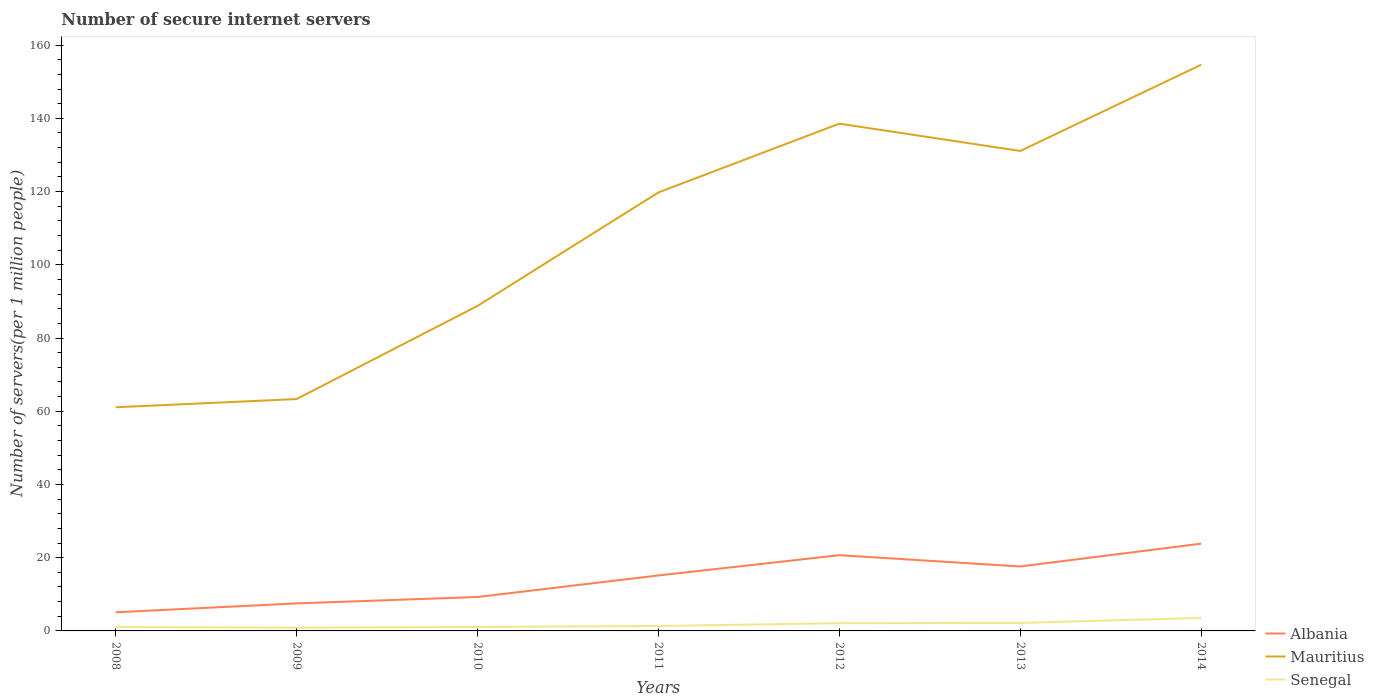How many different coloured lines are there?
Make the answer very short. 3. Does the line corresponding to Mauritius intersect with the line corresponding to Albania?
Give a very brief answer. No. Across all years, what is the maximum number of secure internet servers in Mauritius?
Your answer should be compact. 61.09. What is the total number of secure internet servers in Mauritius in the graph?
Your answer should be very brief. -11.32. What is the difference between the highest and the second highest number of secure internet servers in Senegal?
Your response must be concise. 2.67. How many lines are there?
Offer a terse response. 3. Does the graph contain any zero values?
Provide a succinct answer. No. Does the graph contain grids?
Your answer should be very brief. No. How many legend labels are there?
Ensure brevity in your answer.  3. How are the legend labels stacked?
Your answer should be very brief. Vertical. What is the title of the graph?
Offer a very short reply. Number of secure internet servers. What is the label or title of the X-axis?
Offer a very short reply. Years. What is the label or title of the Y-axis?
Your answer should be very brief. Number of servers(per 1 million people). What is the Number of servers(per 1 million people) of Albania in 2008?
Your response must be concise. 5.09. What is the Number of servers(per 1 million people) in Mauritius in 2008?
Make the answer very short. 61.09. What is the Number of servers(per 1 million people) of Senegal in 2008?
Provide a succinct answer. 1.06. What is the Number of servers(per 1 million people) of Albania in 2009?
Give a very brief answer. 7.51. What is the Number of servers(per 1 million people) of Mauritius in 2009?
Provide a succinct answer. 63.33. What is the Number of servers(per 1 million people) in Senegal in 2009?
Provide a succinct answer. 0.87. What is the Number of servers(per 1 million people) in Albania in 2010?
Provide a short and direct response. 9.27. What is the Number of servers(per 1 million people) in Mauritius in 2010?
Offer a very short reply. 88.77. What is the Number of servers(per 1 million people) in Senegal in 2010?
Give a very brief answer. 1.08. What is the Number of servers(per 1 million people) in Albania in 2011?
Your response must be concise. 15.15. What is the Number of servers(per 1 million people) of Mauritius in 2011?
Give a very brief answer. 119.77. What is the Number of servers(per 1 million people) in Senegal in 2011?
Offer a terse response. 1.35. What is the Number of servers(per 1 million people) of Albania in 2012?
Give a very brief answer. 20.69. What is the Number of servers(per 1 million people) of Mauritius in 2012?
Give a very brief answer. 138.55. What is the Number of servers(per 1 million people) of Senegal in 2012?
Provide a short and direct response. 2.1. What is the Number of servers(per 1 million people) of Albania in 2013?
Your answer should be very brief. 17.6. What is the Number of servers(per 1 million people) of Mauritius in 2013?
Your answer should be compact. 131.09. What is the Number of servers(per 1 million people) of Senegal in 2013?
Offer a terse response. 2.18. What is the Number of servers(per 1 million people) of Albania in 2014?
Your response must be concise. 23.84. What is the Number of servers(per 1 million people) of Mauritius in 2014?
Your answer should be very brief. 154.65. What is the Number of servers(per 1 million people) in Senegal in 2014?
Keep it short and to the point. 3.54. Across all years, what is the maximum Number of servers(per 1 million people) in Albania?
Offer a terse response. 23.84. Across all years, what is the maximum Number of servers(per 1 million people) in Mauritius?
Your response must be concise. 154.65. Across all years, what is the maximum Number of servers(per 1 million people) of Senegal?
Give a very brief answer. 3.54. Across all years, what is the minimum Number of servers(per 1 million people) in Albania?
Keep it short and to the point. 5.09. Across all years, what is the minimum Number of servers(per 1 million people) of Mauritius?
Your response must be concise. 61.09. Across all years, what is the minimum Number of servers(per 1 million people) of Senegal?
Provide a succinct answer. 0.87. What is the total Number of servers(per 1 million people) of Albania in the graph?
Give a very brief answer. 99.15. What is the total Number of servers(per 1 million people) in Mauritius in the graph?
Offer a very short reply. 757.25. What is the total Number of servers(per 1 million people) in Senegal in the graph?
Give a very brief answer. 12.19. What is the difference between the Number of servers(per 1 million people) in Albania in 2008 and that in 2009?
Your answer should be compact. -2.43. What is the difference between the Number of servers(per 1 million people) of Mauritius in 2008 and that in 2009?
Your answer should be compact. -2.24. What is the difference between the Number of servers(per 1 million people) in Senegal in 2008 and that in 2009?
Your response must be concise. 0.19. What is the difference between the Number of servers(per 1 million people) in Albania in 2008 and that in 2010?
Ensure brevity in your answer.  -4.18. What is the difference between the Number of servers(per 1 million people) of Mauritius in 2008 and that in 2010?
Your answer should be very brief. -27.68. What is the difference between the Number of servers(per 1 million people) of Senegal in 2008 and that in 2010?
Your answer should be very brief. -0.02. What is the difference between the Number of servers(per 1 million people) of Albania in 2008 and that in 2011?
Provide a succinct answer. -10.06. What is the difference between the Number of servers(per 1 million people) in Mauritius in 2008 and that in 2011?
Your answer should be compact. -58.68. What is the difference between the Number of servers(per 1 million people) in Senegal in 2008 and that in 2011?
Your response must be concise. -0.28. What is the difference between the Number of servers(per 1 million people) of Albania in 2008 and that in 2012?
Give a very brief answer. -15.6. What is the difference between the Number of servers(per 1 million people) in Mauritius in 2008 and that in 2012?
Offer a terse response. -77.46. What is the difference between the Number of servers(per 1 million people) in Senegal in 2008 and that in 2012?
Provide a succinct answer. -1.04. What is the difference between the Number of servers(per 1 million people) in Albania in 2008 and that in 2013?
Make the answer very short. -12.51. What is the difference between the Number of servers(per 1 million people) of Mauritius in 2008 and that in 2013?
Ensure brevity in your answer.  -70.01. What is the difference between the Number of servers(per 1 million people) of Senegal in 2008 and that in 2013?
Ensure brevity in your answer.  -1.12. What is the difference between the Number of servers(per 1 million people) in Albania in 2008 and that in 2014?
Your response must be concise. -18.75. What is the difference between the Number of servers(per 1 million people) in Mauritius in 2008 and that in 2014?
Provide a succinct answer. -93.56. What is the difference between the Number of servers(per 1 million people) in Senegal in 2008 and that in 2014?
Provide a short and direct response. -2.48. What is the difference between the Number of servers(per 1 million people) in Albania in 2009 and that in 2010?
Ensure brevity in your answer.  -1.75. What is the difference between the Number of servers(per 1 million people) in Mauritius in 2009 and that in 2010?
Keep it short and to the point. -25.44. What is the difference between the Number of servers(per 1 million people) of Senegal in 2009 and that in 2010?
Make the answer very short. -0.21. What is the difference between the Number of servers(per 1 million people) of Albania in 2009 and that in 2011?
Offer a very short reply. -7.63. What is the difference between the Number of servers(per 1 million people) in Mauritius in 2009 and that in 2011?
Your answer should be compact. -56.44. What is the difference between the Number of servers(per 1 million people) in Senegal in 2009 and that in 2011?
Your response must be concise. -0.47. What is the difference between the Number of servers(per 1 million people) in Albania in 2009 and that in 2012?
Keep it short and to the point. -13.17. What is the difference between the Number of servers(per 1 million people) of Mauritius in 2009 and that in 2012?
Offer a terse response. -75.22. What is the difference between the Number of servers(per 1 million people) of Senegal in 2009 and that in 2012?
Provide a succinct answer. -1.23. What is the difference between the Number of servers(per 1 million people) of Albania in 2009 and that in 2013?
Make the answer very short. -10.09. What is the difference between the Number of servers(per 1 million people) of Mauritius in 2009 and that in 2013?
Provide a succinct answer. -67.76. What is the difference between the Number of servers(per 1 million people) in Senegal in 2009 and that in 2013?
Your response must be concise. -1.31. What is the difference between the Number of servers(per 1 million people) in Albania in 2009 and that in 2014?
Give a very brief answer. -16.32. What is the difference between the Number of servers(per 1 million people) of Mauritius in 2009 and that in 2014?
Give a very brief answer. -91.32. What is the difference between the Number of servers(per 1 million people) of Senegal in 2009 and that in 2014?
Provide a succinct answer. -2.67. What is the difference between the Number of servers(per 1 million people) in Albania in 2010 and that in 2011?
Keep it short and to the point. -5.88. What is the difference between the Number of servers(per 1 million people) in Mauritius in 2010 and that in 2011?
Your answer should be compact. -31. What is the difference between the Number of servers(per 1 million people) in Senegal in 2010 and that in 2011?
Keep it short and to the point. -0.27. What is the difference between the Number of servers(per 1 million people) of Albania in 2010 and that in 2012?
Provide a short and direct response. -11.42. What is the difference between the Number of servers(per 1 million people) of Mauritius in 2010 and that in 2012?
Provide a short and direct response. -49.78. What is the difference between the Number of servers(per 1 million people) of Senegal in 2010 and that in 2012?
Provide a succinct answer. -1.02. What is the difference between the Number of servers(per 1 million people) of Albania in 2010 and that in 2013?
Keep it short and to the point. -8.33. What is the difference between the Number of servers(per 1 million people) of Mauritius in 2010 and that in 2013?
Keep it short and to the point. -42.32. What is the difference between the Number of servers(per 1 million people) in Senegal in 2010 and that in 2013?
Make the answer very short. -1.1. What is the difference between the Number of servers(per 1 million people) in Albania in 2010 and that in 2014?
Provide a short and direct response. -14.57. What is the difference between the Number of servers(per 1 million people) in Mauritius in 2010 and that in 2014?
Your answer should be compact. -65.88. What is the difference between the Number of servers(per 1 million people) of Senegal in 2010 and that in 2014?
Offer a very short reply. -2.46. What is the difference between the Number of servers(per 1 million people) of Albania in 2011 and that in 2012?
Make the answer very short. -5.54. What is the difference between the Number of servers(per 1 million people) of Mauritius in 2011 and that in 2012?
Give a very brief answer. -18.78. What is the difference between the Number of servers(per 1 million people) of Senegal in 2011 and that in 2012?
Ensure brevity in your answer.  -0.76. What is the difference between the Number of servers(per 1 million people) of Albania in 2011 and that in 2013?
Your response must be concise. -2.45. What is the difference between the Number of servers(per 1 million people) in Mauritius in 2011 and that in 2013?
Offer a very short reply. -11.32. What is the difference between the Number of servers(per 1 million people) of Senegal in 2011 and that in 2013?
Your answer should be compact. -0.83. What is the difference between the Number of servers(per 1 million people) in Albania in 2011 and that in 2014?
Keep it short and to the point. -8.69. What is the difference between the Number of servers(per 1 million people) in Mauritius in 2011 and that in 2014?
Offer a terse response. -34.88. What is the difference between the Number of servers(per 1 million people) in Senegal in 2011 and that in 2014?
Provide a short and direct response. -2.2. What is the difference between the Number of servers(per 1 million people) in Albania in 2012 and that in 2013?
Keep it short and to the point. 3.08. What is the difference between the Number of servers(per 1 million people) in Mauritius in 2012 and that in 2013?
Keep it short and to the point. 7.46. What is the difference between the Number of servers(per 1 million people) of Senegal in 2012 and that in 2013?
Provide a succinct answer. -0.08. What is the difference between the Number of servers(per 1 million people) in Albania in 2012 and that in 2014?
Your response must be concise. -3.15. What is the difference between the Number of servers(per 1 million people) of Mauritius in 2012 and that in 2014?
Your response must be concise. -16.1. What is the difference between the Number of servers(per 1 million people) of Senegal in 2012 and that in 2014?
Provide a succinct answer. -1.44. What is the difference between the Number of servers(per 1 million people) of Albania in 2013 and that in 2014?
Keep it short and to the point. -6.24. What is the difference between the Number of servers(per 1 million people) of Mauritius in 2013 and that in 2014?
Make the answer very short. -23.55. What is the difference between the Number of servers(per 1 million people) in Senegal in 2013 and that in 2014?
Provide a short and direct response. -1.36. What is the difference between the Number of servers(per 1 million people) in Albania in 2008 and the Number of servers(per 1 million people) in Mauritius in 2009?
Ensure brevity in your answer.  -58.24. What is the difference between the Number of servers(per 1 million people) of Albania in 2008 and the Number of servers(per 1 million people) of Senegal in 2009?
Provide a short and direct response. 4.22. What is the difference between the Number of servers(per 1 million people) of Mauritius in 2008 and the Number of servers(per 1 million people) of Senegal in 2009?
Ensure brevity in your answer.  60.21. What is the difference between the Number of servers(per 1 million people) in Albania in 2008 and the Number of servers(per 1 million people) in Mauritius in 2010?
Keep it short and to the point. -83.68. What is the difference between the Number of servers(per 1 million people) in Albania in 2008 and the Number of servers(per 1 million people) in Senegal in 2010?
Make the answer very short. 4.01. What is the difference between the Number of servers(per 1 million people) in Mauritius in 2008 and the Number of servers(per 1 million people) in Senegal in 2010?
Keep it short and to the point. 60.01. What is the difference between the Number of servers(per 1 million people) in Albania in 2008 and the Number of servers(per 1 million people) in Mauritius in 2011?
Provide a succinct answer. -114.68. What is the difference between the Number of servers(per 1 million people) of Albania in 2008 and the Number of servers(per 1 million people) of Senegal in 2011?
Your answer should be compact. 3.74. What is the difference between the Number of servers(per 1 million people) in Mauritius in 2008 and the Number of servers(per 1 million people) in Senegal in 2011?
Provide a succinct answer. 59.74. What is the difference between the Number of servers(per 1 million people) of Albania in 2008 and the Number of servers(per 1 million people) of Mauritius in 2012?
Keep it short and to the point. -133.46. What is the difference between the Number of servers(per 1 million people) in Albania in 2008 and the Number of servers(per 1 million people) in Senegal in 2012?
Your answer should be very brief. 2.98. What is the difference between the Number of servers(per 1 million people) of Mauritius in 2008 and the Number of servers(per 1 million people) of Senegal in 2012?
Offer a terse response. 58.98. What is the difference between the Number of servers(per 1 million people) of Albania in 2008 and the Number of servers(per 1 million people) of Mauritius in 2013?
Ensure brevity in your answer.  -126. What is the difference between the Number of servers(per 1 million people) in Albania in 2008 and the Number of servers(per 1 million people) in Senegal in 2013?
Give a very brief answer. 2.91. What is the difference between the Number of servers(per 1 million people) in Mauritius in 2008 and the Number of servers(per 1 million people) in Senegal in 2013?
Offer a terse response. 58.91. What is the difference between the Number of servers(per 1 million people) of Albania in 2008 and the Number of servers(per 1 million people) of Mauritius in 2014?
Keep it short and to the point. -149.56. What is the difference between the Number of servers(per 1 million people) in Albania in 2008 and the Number of servers(per 1 million people) in Senegal in 2014?
Offer a terse response. 1.55. What is the difference between the Number of servers(per 1 million people) of Mauritius in 2008 and the Number of servers(per 1 million people) of Senegal in 2014?
Make the answer very short. 57.54. What is the difference between the Number of servers(per 1 million people) of Albania in 2009 and the Number of servers(per 1 million people) of Mauritius in 2010?
Your response must be concise. -81.26. What is the difference between the Number of servers(per 1 million people) of Albania in 2009 and the Number of servers(per 1 million people) of Senegal in 2010?
Ensure brevity in your answer.  6.43. What is the difference between the Number of servers(per 1 million people) of Mauritius in 2009 and the Number of servers(per 1 million people) of Senegal in 2010?
Make the answer very short. 62.25. What is the difference between the Number of servers(per 1 million people) in Albania in 2009 and the Number of servers(per 1 million people) in Mauritius in 2011?
Your answer should be very brief. -112.25. What is the difference between the Number of servers(per 1 million people) of Albania in 2009 and the Number of servers(per 1 million people) of Senegal in 2011?
Your response must be concise. 6.17. What is the difference between the Number of servers(per 1 million people) of Mauritius in 2009 and the Number of servers(per 1 million people) of Senegal in 2011?
Ensure brevity in your answer.  61.98. What is the difference between the Number of servers(per 1 million people) in Albania in 2009 and the Number of servers(per 1 million people) in Mauritius in 2012?
Your answer should be very brief. -131.03. What is the difference between the Number of servers(per 1 million people) of Albania in 2009 and the Number of servers(per 1 million people) of Senegal in 2012?
Ensure brevity in your answer.  5.41. What is the difference between the Number of servers(per 1 million people) of Mauritius in 2009 and the Number of servers(per 1 million people) of Senegal in 2012?
Your answer should be compact. 61.23. What is the difference between the Number of servers(per 1 million people) of Albania in 2009 and the Number of servers(per 1 million people) of Mauritius in 2013?
Keep it short and to the point. -123.58. What is the difference between the Number of servers(per 1 million people) in Albania in 2009 and the Number of servers(per 1 million people) in Senegal in 2013?
Provide a succinct answer. 5.33. What is the difference between the Number of servers(per 1 million people) of Mauritius in 2009 and the Number of servers(per 1 million people) of Senegal in 2013?
Your response must be concise. 61.15. What is the difference between the Number of servers(per 1 million people) in Albania in 2009 and the Number of servers(per 1 million people) in Mauritius in 2014?
Your answer should be compact. -147.13. What is the difference between the Number of servers(per 1 million people) in Albania in 2009 and the Number of servers(per 1 million people) in Senegal in 2014?
Provide a succinct answer. 3.97. What is the difference between the Number of servers(per 1 million people) of Mauritius in 2009 and the Number of servers(per 1 million people) of Senegal in 2014?
Make the answer very short. 59.79. What is the difference between the Number of servers(per 1 million people) of Albania in 2010 and the Number of servers(per 1 million people) of Mauritius in 2011?
Provide a succinct answer. -110.5. What is the difference between the Number of servers(per 1 million people) of Albania in 2010 and the Number of servers(per 1 million people) of Senegal in 2011?
Make the answer very short. 7.92. What is the difference between the Number of servers(per 1 million people) of Mauritius in 2010 and the Number of servers(per 1 million people) of Senegal in 2011?
Provide a succinct answer. 87.42. What is the difference between the Number of servers(per 1 million people) in Albania in 2010 and the Number of servers(per 1 million people) in Mauritius in 2012?
Provide a short and direct response. -129.28. What is the difference between the Number of servers(per 1 million people) in Albania in 2010 and the Number of servers(per 1 million people) in Senegal in 2012?
Ensure brevity in your answer.  7.16. What is the difference between the Number of servers(per 1 million people) of Mauritius in 2010 and the Number of servers(per 1 million people) of Senegal in 2012?
Give a very brief answer. 86.67. What is the difference between the Number of servers(per 1 million people) in Albania in 2010 and the Number of servers(per 1 million people) in Mauritius in 2013?
Provide a succinct answer. -121.82. What is the difference between the Number of servers(per 1 million people) of Albania in 2010 and the Number of servers(per 1 million people) of Senegal in 2013?
Keep it short and to the point. 7.09. What is the difference between the Number of servers(per 1 million people) of Mauritius in 2010 and the Number of servers(per 1 million people) of Senegal in 2013?
Make the answer very short. 86.59. What is the difference between the Number of servers(per 1 million people) in Albania in 2010 and the Number of servers(per 1 million people) in Mauritius in 2014?
Ensure brevity in your answer.  -145.38. What is the difference between the Number of servers(per 1 million people) in Albania in 2010 and the Number of servers(per 1 million people) in Senegal in 2014?
Make the answer very short. 5.72. What is the difference between the Number of servers(per 1 million people) in Mauritius in 2010 and the Number of servers(per 1 million people) in Senegal in 2014?
Keep it short and to the point. 85.23. What is the difference between the Number of servers(per 1 million people) in Albania in 2011 and the Number of servers(per 1 million people) in Mauritius in 2012?
Your answer should be very brief. -123.4. What is the difference between the Number of servers(per 1 million people) in Albania in 2011 and the Number of servers(per 1 million people) in Senegal in 2012?
Provide a succinct answer. 13.04. What is the difference between the Number of servers(per 1 million people) in Mauritius in 2011 and the Number of servers(per 1 million people) in Senegal in 2012?
Provide a succinct answer. 117.67. What is the difference between the Number of servers(per 1 million people) in Albania in 2011 and the Number of servers(per 1 million people) in Mauritius in 2013?
Your answer should be compact. -115.95. What is the difference between the Number of servers(per 1 million people) of Albania in 2011 and the Number of servers(per 1 million people) of Senegal in 2013?
Your answer should be compact. 12.97. What is the difference between the Number of servers(per 1 million people) in Mauritius in 2011 and the Number of servers(per 1 million people) in Senegal in 2013?
Provide a succinct answer. 117.59. What is the difference between the Number of servers(per 1 million people) of Albania in 2011 and the Number of servers(per 1 million people) of Mauritius in 2014?
Give a very brief answer. -139.5. What is the difference between the Number of servers(per 1 million people) of Albania in 2011 and the Number of servers(per 1 million people) of Senegal in 2014?
Ensure brevity in your answer.  11.6. What is the difference between the Number of servers(per 1 million people) of Mauritius in 2011 and the Number of servers(per 1 million people) of Senegal in 2014?
Give a very brief answer. 116.23. What is the difference between the Number of servers(per 1 million people) in Albania in 2012 and the Number of servers(per 1 million people) in Mauritius in 2013?
Provide a succinct answer. -110.41. What is the difference between the Number of servers(per 1 million people) of Albania in 2012 and the Number of servers(per 1 million people) of Senegal in 2013?
Your answer should be very brief. 18.51. What is the difference between the Number of servers(per 1 million people) in Mauritius in 2012 and the Number of servers(per 1 million people) in Senegal in 2013?
Offer a terse response. 136.37. What is the difference between the Number of servers(per 1 million people) in Albania in 2012 and the Number of servers(per 1 million people) in Mauritius in 2014?
Your answer should be very brief. -133.96. What is the difference between the Number of servers(per 1 million people) of Albania in 2012 and the Number of servers(per 1 million people) of Senegal in 2014?
Give a very brief answer. 17.14. What is the difference between the Number of servers(per 1 million people) in Mauritius in 2012 and the Number of servers(per 1 million people) in Senegal in 2014?
Provide a succinct answer. 135. What is the difference between the Number of servers(per 1 million people) of Albania in 2013 and the Number of servers(per 1 million people) of Mauritius in 2014?
Your answer should be compact. -137.05. What is the difference between the Number of servers(per 1 million people) in Albania in 2013 and the Number of servers(per 1 million people) in Senegal in 2014?
Give a very brief answer. 14.06. What is the difference between the Number of servers(per 1 million people) of Mauritius in 2013 and the Number of servers(per 1 million people) of Senegal in 2014?
Your answer should be compact. 127.55. What is the average Number of servers(per 1 million people) in Albania per year?
Keep it short and to the point. 14.16. What is the average Number of servers(per 1 million people) in Mauritius per year?
Give a very brief answer. 108.18. What is the average Number of servers(per 1 million people) in Senegal per year?
Offer a very short reply. 1.74. In the year 2008, what is the difference between the Number of servers(per 1 million people) in Albania and Number of servers(per 1 million people) in Mauritius?
Offer a terse response. -56. In the year 2008, what is the difference between the Number of servers(per 1 million people) in Albania and Number of servers(per 1 million people) in Senegal?
Your answer should be very brief. 4.03. In the year 2008, what is the difference between the Number of servers(per 1 million people) in Mauritius and Number of servers(per 1 million people) in Senegal?
Keep it short and to the point. 60.02. In the year 2009, what is the difference between the Number of servers(per 1 million people) in Albania and Number of servers(per 1 million people) in Mauritius?
Provide a succinct answer. -55.82. In the year 2009, what is the difference between the Number of servers(per 1 million people) in Albania and Number of servers(per 1 million people) in Senegal?
Give a very brief answer. 6.64. In the year 2009, what is the difference between the Number of servers(per 1 million people) of Mauritius and Number of servers(per 1 million people) of Senegal?
Your answer should be very brief. 62.46. In the year 2010, what is the difference between the Number of servers(per 1 million people) of Albania and Number of servers(per 1 million people) of Mauritius?
Your answer should be compact. -79.5. In the year 2010, what is the difference between the Number of servers(per 1 million people) of Albania and Number of servers(per 1 million people) of Senegal?
Your answer should be very brief. 8.19. In the year 2010, what is the difference between the Number of servers(per 1 million people) in Mauritius and Number of servers(per 1 million people) in Senegal?
Ensure brevity in your answer.  87.69. In the year 2011, what is the difference between the Number of servers(per 1 million people) in Albania and Number of servers(per 1 million people) in Mauritius?
Your answer should be very brief. -104.62. In the year 2011, what is the difference between the Number of servers(per 1 million people) of Albania and Number of servers(per 1 million people) of Senegal?
Offer a very short reply. 13.8. In the year 2011, what is the difference between the Number of servers(per 1 million people) in Mauritius and Number of servers(per 1 million people) in Senegal?
Give a very brief answer. 118.42. In the year 2012, what is the difference between the Number of servers(per 1 million people) in Albania and Number of servers(per 1 million people) in Mauritius?
Keep it short and to the point. -117.86. In the year 2012, what is the difference between the Number of servers(per 1 million people) of Albania and Number of servers(per 1 million people) of Senegal?
Ensure brevity in your answer.  18.58. In the year 2012, what is the difference between the Number of servers(per 1 million people) of Mauritius and Number of servers(per 1 million people) of Senegal?
Provide a succinct answer. 136.44. In the year 2013, what is the difference between the Number of servers(per 1 million people) of Albania and Number of servers(per 1 million people) of Mauritius?
Offer a very short reply. -113.49. In the year 2013, what is the difference between the Number of servers(per 1 million people) in Albania and Number of servers(per 1 million people) in Senegal?
Provide a short and direct response. 15.42. In the year 2013, what is the difference between the Number of servers(per 1 million people) of Mauritius and Number of servers(per 1 million people) of Senegal?
Keep it short and to the point. 128.91. In the year 2014, what is the difference between the Number of servers(per 1 million people) in Albania and Number of servers(per 1 million people) in Mauritius?
Provide a succinct answer. -130.81. In the year 2014, what is the difference between the Number of servers(per 1 million people) in Albania and Number of servers(per 1 million people) in Senegal?
Your answer should be very brief. 20.29. In the year 2014, what is the difference between the Number of servers(per 1 million people) of Mauritius and Number of servers(per 1 million people) of Senegal?
Provide a succinct answer. 151.1. What is the ratio of the Number of servers(per 1 million people) of Albania in 2008 to that in 2009?
Provide a succinct answer. 0.68. What is the ratio of the Number of servers(per 1 million people) in Mauritius in 2008 to that in 2009?
Give a very brief answer. 0.96. What is the ratio of the Number of servers(per 1 million people) of Senegal in 2008 to that in 2009?
Your response must be concise. 1.22. What is the ratio of the Number of servers(per 1 million people) of Albania in 2008 to that in 2010?
Provide a succinct answer. 0.55. What is the ratio of the Number of servers(per 1 million people) in Mauritius in 2008 to that in 2010?
Provide a short and direct response. 0.69. What is the ratio of the Number of servers(per 1 million people) of Senegal in 2008 to that in 2010?
Offer a terse response. 0.98. What is the ratio of the Number of servers(per 1 million people) in Albania in 2008 to that in 2011?
Make the answer very short. 0.34. What is the ratio of the Number of servers(per 1 million people) of Mauritius in 2008 to that in 2011?
Your answer should be very brief. 0.51. What is the ratio of the Number of servers(per 1 million people) of Senegal in 2008 to that in 2011?
Your answer should be compact. 0.79. What is the ratio of the Number of servers(per 1 million people) of Albania in 2008 to that in 2012?
Ensure brevity in your answer.  0.25. What is the ratio of the Number of servers(per 1 million people) of Mauritius in 2008 to that in 2012?
Your answer should be compact. 0.44. What is the ratio of the Number of servers(per 1 million people) of Senegal in 2008 to that in 2012?
Give a very brief answer. 0.51. What is the ratio of the Number of servers(per 1 million people) in Albania in 2008 to that in 2013?
Offer a terse response. 0.29. What is the ratio of the Number of servers(per 1 million people) of Mauritius in 2008 to that in 2013?
Your response must be concise. 0.47. What is the ratio of the Number of servers(per 1 million people) in Senegal in 2008 to that in 2013?
Provide a succinct answer. 0.49. What is the ratio of the Number of servers(per 1 million people) in Albania in 2008 to that in 2014?
Ensure brevity in your answer.  0.21. What is the ratio of the Number of servers(per 1 million people) in Mauritius in 2008 to that in 2014?
Provide a short and direct response. 0.4. What is the ratio of the Number of servers(per 1 million people) of Senegal in 2008 to that in 2014?
Offer a very short reply. 0.3. What is the ratio of the Number of servers(per 1 million people) of Albania in 2009 to that in 2010?
Provide a succinct answer. 0.81. What is the ratio of the Number of servers(per 1 million people) of Mauritius in 2009 to that in 2010?
Offer a terse response. 0.71. What is the ratio of the Number of servers(per 1 million people) in Senegal in 2009 to that in 2010?
Provide a succinct answer. 0.81. What is the ratio of the Number of servers(per 1 million people) of Albania in 2009 to that in 2011?
Your answer should be compact. 0.5. What is the ratio of the Number of servers(per 1 million people) of Mauritius in 2009 to that in 2011?
Your answer should be compact. 0.53. What is the ratio of the Number of servers(per 1 million people) in Senegal in 2009 to that in 2011?
Give a very brief answer. 0.65. What is the ratio of the Number of servers(per 1 million people) in Albania in 2009 to that in 2012?
Your answer should be very brief. 0.36. What is the ratio of the Number of servers(per 1 million people) of Mauritius in 2009 to that in 2012?
Offer a very short reply. 0.46. What is the ratio of the Number of servers(per 1 million people) in Senegal in 2009 to that in 2012?
Your answer should be very brief. 0.42. What is the ratio of the Number of servers(per 1 million people) of Albania in 2009 to that in 2013?
Your response must be concise. 0.43. What is the ratio of the Number of servers(per 1 million people) of Mauritius in 2009 to that in 2013?
Provide a short and direct response. 0.48. What is the ratio of the Number of servers(per 1 million people) in Senegal in 2009 to that in 2013?
Offer a terse response. 0.4. What is the ratio of the Number of servers(per 1 million people) of Albania in 2009 to that in 2014?
Give a very brief answer. 0.32. What is the ratio of the Number of servers(per 1 million people) of Mauritius in 2009 to that in 2014?
Offer a terse response. 0.41. What is the ratio of the Number of servers(per 1 million people) of Senegal in 2009 to that in 2014?
Your answer should be very brief. 0.25. What is the ratio of the Number of servers(per 1 million people) of Albania in 2010 to that in 2011?
Ensure brevity in your answer.  0.61. What is the ratio of the Number of servers(per 1 million people) in Mauritius in 2010 to that in 2011?
Provide a short and direct response. 0.74. What is the ratio of the Number of servers(per 1 million people) in Senegal in 2010 to that in 2011?
Make the answer very short. 0.8. What is the ratio of the Number of servers(per 1 million people) of Albania in 2010 to that in 2012?
Your answer should be compact. 0.45. What is the ratio of the Number of servers(per 1 million people) of Mauritius in 2010 to that in 2012?
Provide a short and direct response. 0.64. What is the ratio of the Number of servers(per 1 million people) of Senegal in 2010 to that in 2012?
Make the answer very short. 0.51. What is the ratio of the Number of servers(per 1 million people) of Albania in 2010 to that in 2013?
Your response must be concise. 0.53. What is the ratio of the Number of servers(per 1 million people) of Mauritius in 2010 to that in 2013?
Offer a terse response. 0.68. What is the ratio of the Number of servers(per 1 million people) in Senegal in 2010 to that in 2013?
Your response must be concise. 0.5. What is the ratio of the Number of servers(per 1 million people) in Albania in 2010 to that in 2014?
Your answer should be compact. 0.39. What is the ratio of the Number of servers(per 1 million people) of Mauritius in 2010 to that in 2014?
Keep it short and to the point. 0.57. What is the ratio of the Number of servers(per 1 million people) of Senegal in 2010 to that in 2014?
Keep it short and to the point. 0.3. What is the ratio of the Number of servers(per 1 million people) of Albania in 2011 to that in 2012?
Provide a succinct answer. 0.73. What is the ratio of the Number of servers(per 1 million people) of Mauritius in 2011 to that in 2012?
Keep it short and to the point. 0.86. What is the ratio of the Number of servers(per 1 million people) of Senegal in 2011 to that in 2012?
Provide a short and direct response. 0.64. What is the ratio of the Number of servers(per 1 million people) in Albania in 2011 to that in 2013?
Keep it short and to the point. 0.86. What is the ratio of the Number of servers(per 1 million people) of Mauritius in 2011 to that in 2013?
Ensure brevity in your answer.  0.91. What is the ratio of the Number of servers(per 1 million people) in Senegal in 2011 to that in 2013?
Provide a succinct answer. 0.62. What is the ratio of the Number of servers(per 1 million people) of Albania in 2011 to that in 2014?
Offer a very short reply. 0.64. What is the ratio of the Number of servers(per 1 million people) in Mauritius in 2011 to that in 2014?
Provide a succinct answer. 0.77. What is the ratio of the Number of servers(per 1 million people) in Senegal in 2011 to that in 2014?
Your response must be concise. 0.38. What is the ratio of the Number of servers(per 1 million people) of Albania in 2012 to that in 2013?
Ensure brevity in your answer.  1.18. What is the ratio of the Number of servers(per 1 million people) in Mauritius in 2012 to that in 2013?
Offer a very short reply. 1.06. What is the ratio of the Number of servers(per 1 million people) of Senegal in 2012 to that in 2013?
Provide a short and direct response. 0.97. What is the ratio of the Number of servers(per 1 million people) in Albania in 2012 to that in 2014?
Make the answer very short. 0.87. What is the ratio of the Number of servers(per 1 million people) in Mauritius in 2012 to that in 2014?
Offer a terse response. 0.9. What is the ratio of the Number of servers(per 1 million people) of Senegal in 2012 to that in 2014?
Your response must be concise. 0.59. What is the ratio of the Number of servers(per 1 million people) of Albania in 2013 to that in 2014?
Offer a terse response. 0.74. What is the ratio of the Number of servers(per 1 million people) of Mauritius in 2013 to that in 2014?
Your response must be concise. 0.85. What is the ratio of the Number of servers(per 1 million people) of Senegal in 2013 to that in 2014?
Offer a terse response. 0.62. What is the difference between the highest and the second highest Number of servers(per 1 million people) of Albania?
Your answer should be compact. 3.15. What is the difference between the highest and the second highest Number of servers(per 1 million people) in Mauritius?
Offer a very short reply. 16.1. What is the difference between the highest and the second highest Number of servers(per 1 million people) of Senegal?
Provide a succinct answer. 1.36. What is the difference between the highest and the lowest Number of servers(per 1 million people) of Albania?
Make the answer very short. 18.75. What is the difference between the highest and the lowest Number of servers(per 1 million people) in Mauritius?
Offer a very short reply. 93.56. What is the difference between the highest and the lowest Number of servers(per 1 million people) of Senegal?
Keep it short and to the point. 2.67. 